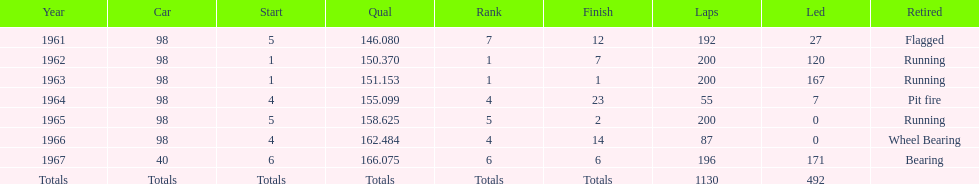Which car reached the top qualification level? 40. 